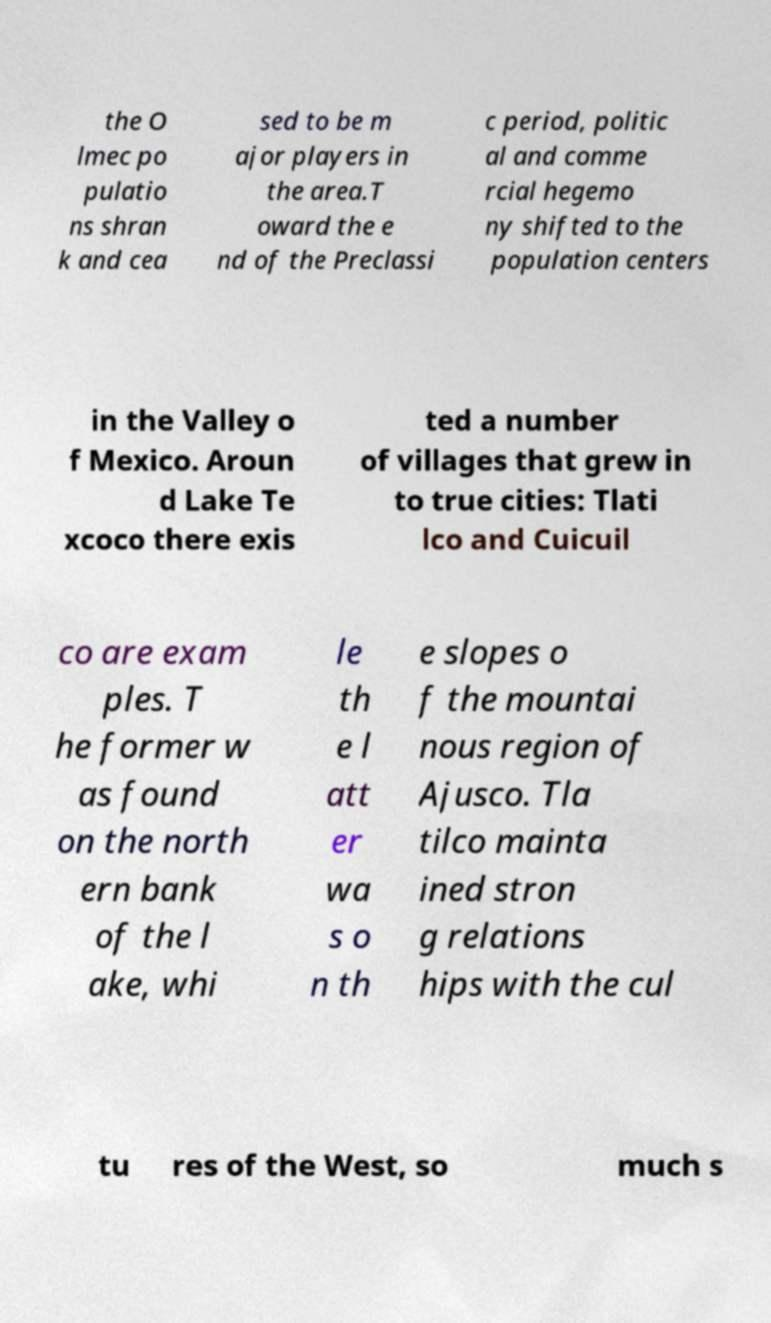Could you assist in decoding the text presented in this image and type it out clearly? the O lmec po pulatio ns shran k and cea sed to be m ajor players in the area.T oward the e nd of the Preclassi c period, politic al and comme rcial hegemo ny shifted to the population centers in the Valley o f Mexico. Aroun d Lake Te xcoco there exis ted a number of villages that grew in to true cities: Tlati lco and Cuicuil co are exam ples. T he former w as found on the north ern bank of the l ake, whi le th e l att er wa s o n th e slopes o f the mountai nous region of Ajusco. Tla tilco mainta ined stron g relations hips with the cul tu res of the West, so much s 